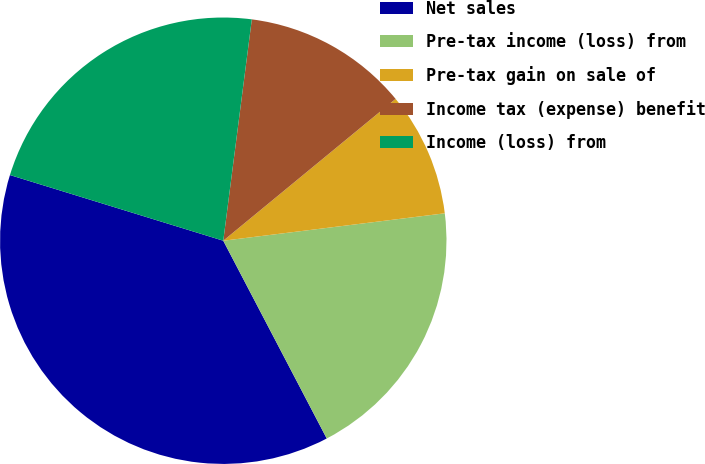Convert chart to OTSL. <chart><loc_0><loc_0><loc_500><loc_500><pie_chart><fcel>Net sales<fcel>Pre-tax income (loss) from<fcel>Pre-tax gain on sale of<fcel>Income tax (expense) benefit<fcel>Income (loss) from<nl><fcel>37.43%<fcel>19.29%<fcel>9.0%<fcel>12.0%<fcel>22.29%<nl></chart> 